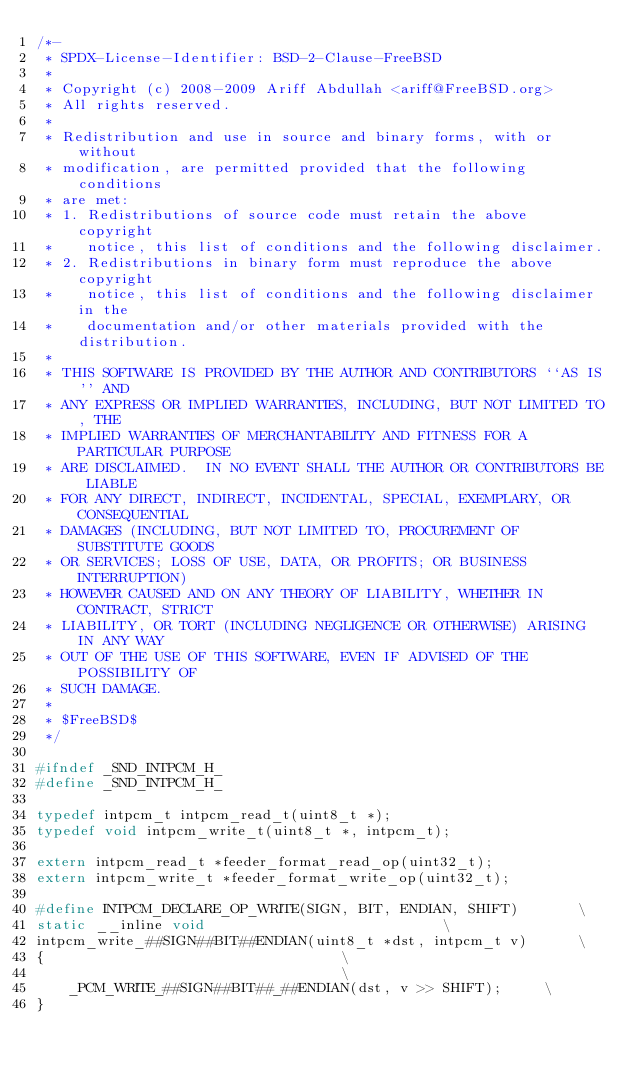<code> <loc_0><loc_0><loc_500><loc_500><_C_>/*-
 * SPDX-License-Identifier: BSD-2-Clause-FreeBSD
 *
 * Copyright (c) 2008-2009 Ariff Abdullah <ariff@FreeBSD.org>
 * All rights reserved.
 *
 * Redistribution and use in source and binary forms, with or without
 * modification, are permitted provided that the following conditions
 * are met:
 * 1. Redistributions of source code must retain the above copyright
 *    notice, this list of conditions and the following disclaimer.
 * 2. Redistributions in binary form must reproduce the above copyright
 *    notice, this list of conditions and the following disclaimer in the
 *    documentation and/or other materials provided with the distribution.
 *
 * THIS SOFTWARE IS PROVIDED BY THE AUTHOR AND CONTRIBUTORS ``AS IS'' AND
 * ANY EXPRESS OR IMPLIED WARRANTIES, INCLUDING, BUT NOT LIMITED TO, THE
 * IMPLIED WARRANTIES OF MERCHANTABILITY AND FITNESS FOR A PARTICULAR PURPOSE
 * ARE DISCLAIMED.  IN NO EVENT SHALL THE AUTHOR OR CONTRIBUTORS BE LIABLE
 * FOR ANY DIRECT, INDIRECT, INCIDENTAL, SPECIAL, EXEMPLARY, OR CONSEQUENTIAL
 * DAMAGES (INCLUDING, BUT NOT LIMITED TO, PROCUREMENT OF SUBSTITUTE GOODS
 * OR SERVICES; LOSS OF USE, DATA, OR PROFITS; OR BUSINESS INTERRUPTION)
 * HOWEVER CAUSED AND ON ANY THEORY OF LIABILITY, WHETHER IN CONTRACT, STRICT
 * LIABILITY, OR TORT (INCLUDING NEGLIGENCE OR OTHERWISE) ARISING IN ANY WAY
 * OUT OF THE USE OF THIS SOFTWARE, EVEN IF ADVISED OF THE POSSIBILITY OF
 * SUCH DAMAGE.
 *
 * $FreeBSD$
 */

#ifndef _SND_INTPCM_H_
#define _SND_INTPCM_H_

typedef intpcm_t intpcm_read_t(uint8_t *);
typedef void intpcm_write_t(uint8_t *, intpcm_t);

extern intpcm_read_t *feeder_format_read_op(uint32_t);
extern intpcm_write_t *feeder_format_write_op(uint32_t);

#define INTPCM_DECLARE_OP_WRITE(SIGN, BIT, ENDIAN, SHIFT)		\
static __inline void							\
intpcm_write_##SIGN##BIT##ENDIAN(uint8_t *dst, intpcm_t v)		\
{									\
									\
	_PCM_WRITE_##SIGN##BIT##_##ENDIAN(dst, v >> SHIFT);		\
}
</code> 